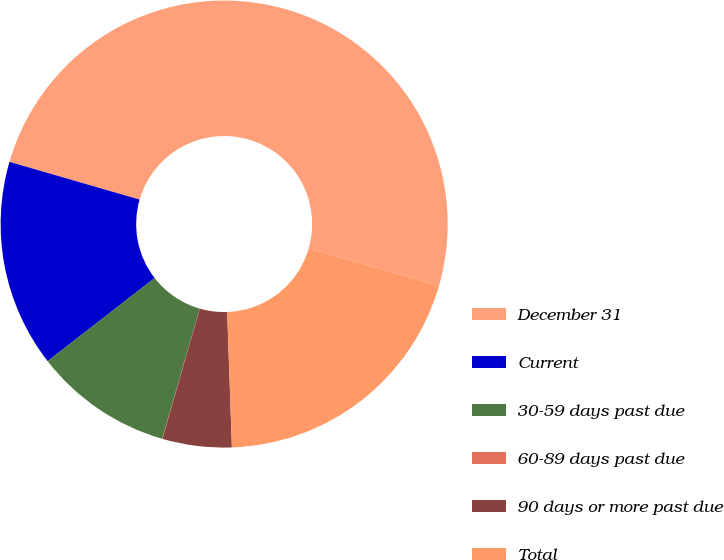<chart> <loc_0><loc_0><loc_500><loc_500><pie_chart><fcel>December 31<fcel>Current<fcel>30-59 days past due<fcel>60-89 days past due<fcel>90 days or more past due<fcel>Total<nl><fcel>49.96%<fcel>15.0%<fcel>10.01%<fcel>0.02%<fcel>5.01%<fcel>20.0%<nl></chart> 